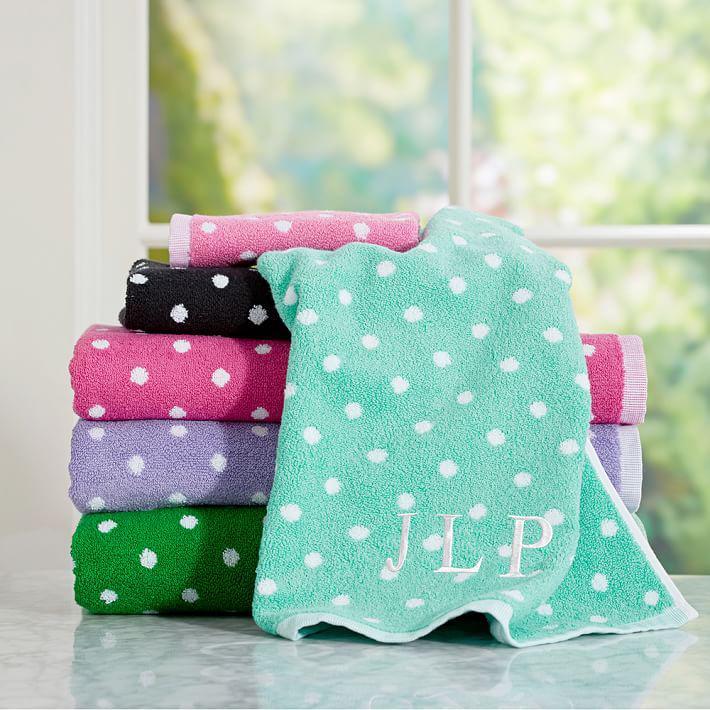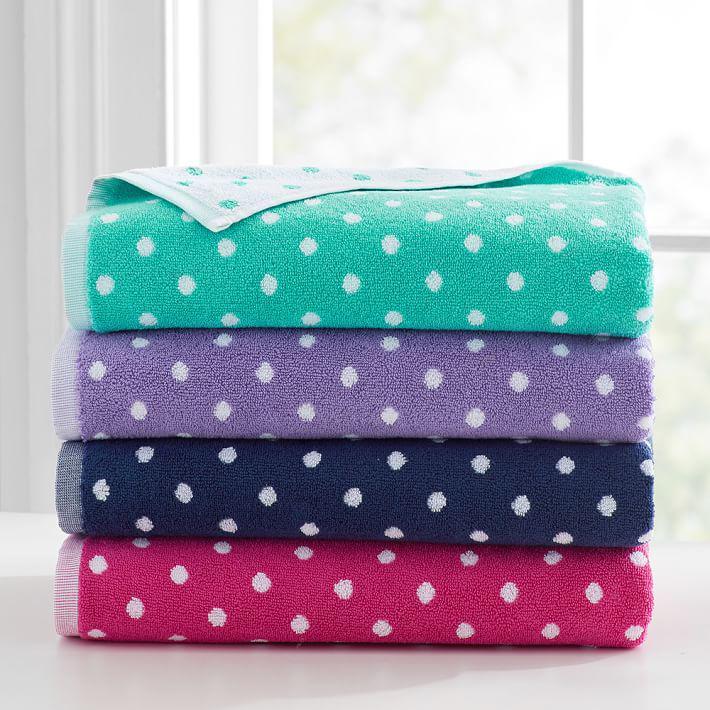The first image is the image on the left, the second image is the image on the right. Evaluate the accuracy of this statement regarding the images: "All images contain towels with a spotted pattern.". Is it true? Answer yes or no. Yes. The first image is the image on the left, the second image is the image on the right. For the images displayed, is the sentence "A black towel is folded under a green folded towel." factually correct? Answer yes or no. No. 